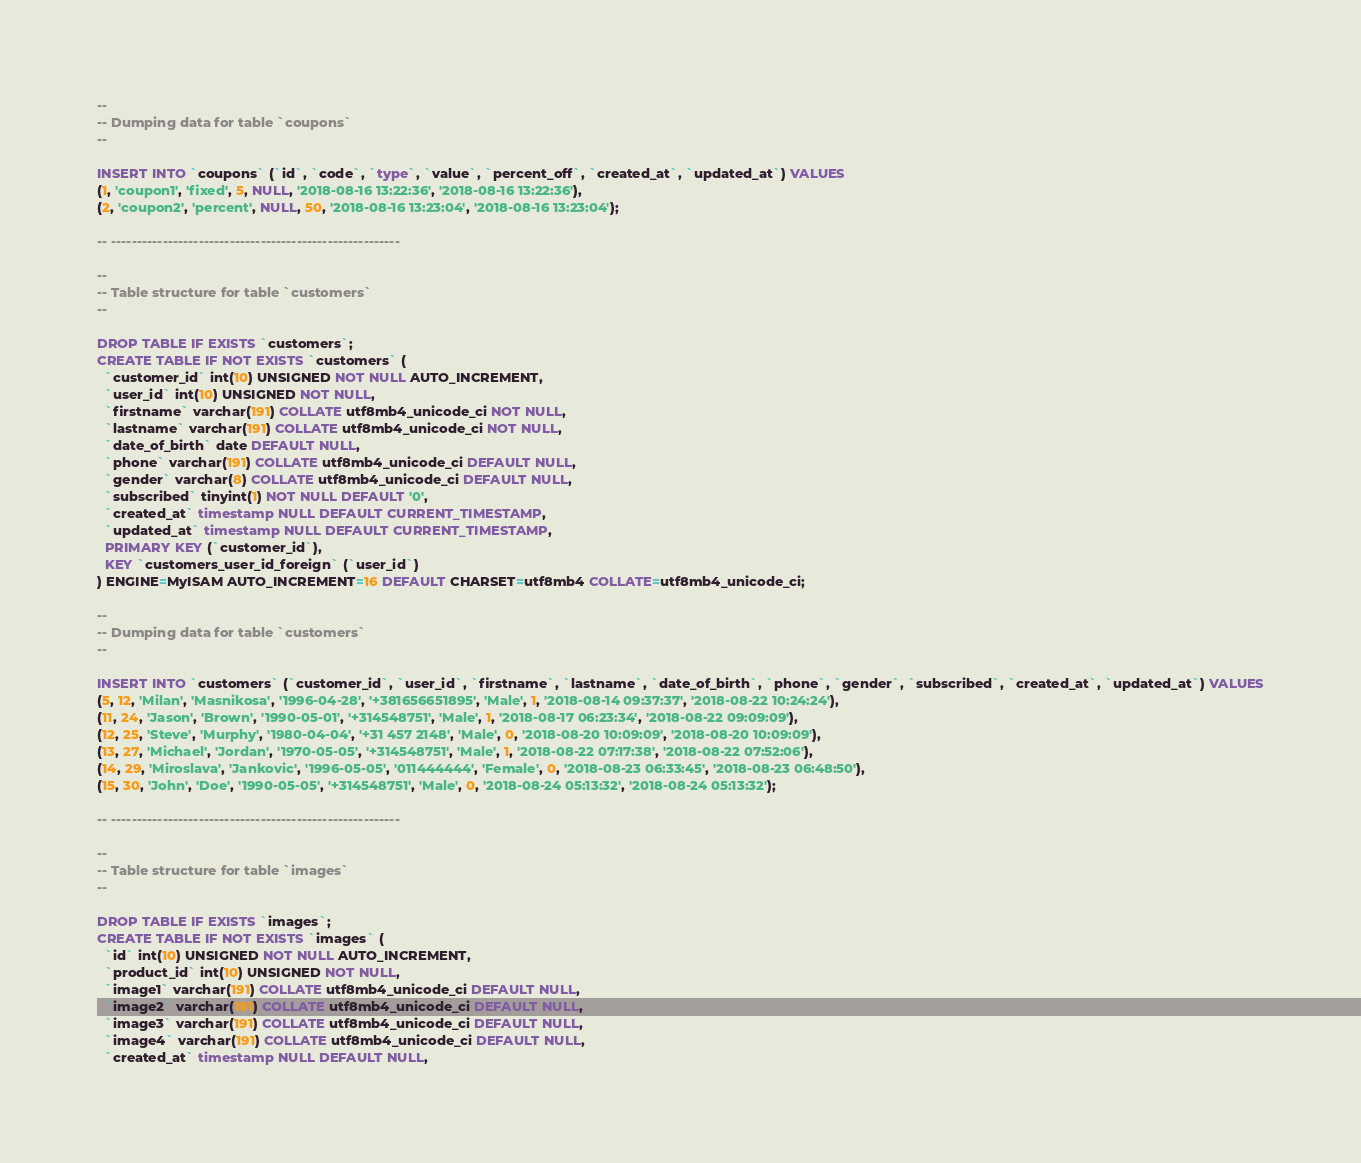Convert code to text. <code><loc_0><loc_0><loc_500><loc_500><_SQL_>--
-- Dumping data for table `coupons`
--

INSERT INTO `coupons` (`id`, `code`, `type`, `value`, `percent_off`, `created_at`, `updated_at`) VALUES
(1, 'coupon1', 'fixed', 5, NULL, '2018-08-16 13:22:36', '2018-08-16 13:22:36'),
(2, 'coupon2', 'percent', NULL, 50, '2018-08-16 13:23:04', '2018-08-16 13:23:04');

-- --------------------------------------------------------

--
-- Table structure for table `customers`
--

DROP TABLE IF EXISTS `customers`;
CREATE TABLE IF NOT EXISTS `customers` (
  `customer_id` int(10) UNSIGNED NOT NULL AUTO_INCREMENT,
  `user_id` int(10) UNSIGNED NOT NULL,
  `firstname` varchar(191) COLLATE utf8mb4_unicode_ci NOT NULL,
  `lastname` varchar(191) COLLATE utf8mb4_unicode_ci NOT NULL,
  `date_of_birth` date DEFAULT NULL,
  `phone` varchar(191) COLLATE utf8mb4_unicode_ci DEFAULT NULL,
  `gender` varchar(8) COLLATE utf8mb4_unicode_ci DEFAULT NULL,
  `subscribed` tinyint(1) NOT NULL DEFAULT '0',
  `created_at` timestamp NULL DEFAULT CURRENT_TIMESTAMP,
  `updated_at` timestamp NULL DEFAULT CURRENT_TIMESTAMP,
  PRIMARY KEY (`customer_id`),
  KEY `customers_user_id_foreign` (`user_id`)
) ENGINE=MyISAM AUTO_INCREMENT=16 DEFAULT CHARSET=utf8mb4 COLLATE=utf8mb4_unicode_ci;

--
-- Dumping data for table `customers`
--

INSERT INTO `customers` (`customer_id`, `user_id`, `firstname`, `lastname`, `date_of_birth`, `phone`, `gender`, `subscribed`, `created_at`, `updated_at`) VALUES
(5, 12, 'Milan', 'Masnikosa', '1996-04-28', '+381656651895', 'Male', 1, '2018-08-14 09:37:37', '2018-08-22 10:24:24'),
(11, 24, 'Jason', 'Brown', '1990-05-01', '+314548751', 'Male', 1, '2018-08-17 06:23:34', '2018-08-22 09:09:09'),
(12, 25, 'Steve', 'Murphy', '1980-04-04', '+31 457 2148', 'Male', 0, '2018-08-20 10:09:09', '2018-08-20 10:09:09'),
(13, 27, 'Michael', 'Jordan', '1970-05-05', '+314548751', 'Male', 1, '2018-08-22 07:17:38', '2018-08-22 07:52:06'),
(14, 29, 'Miroslava', 'Jankovic', '1996-05-05', '011444444', 'Female', 0, '2018-08-23 06:33:45', '2018-08-23 06:48:50'),
(15, 30, 'John', 'Doe', '1990-05-05', '+314548751', 'Male', 0, '2018-08-24 05:13:32', '2018-08-24 05:13:32');

-- --------------------------------------------------------

--
-- Table structure for table `images`
--

DROP TABLE IF EXISTS `images`;
CREATE TABLE IF NOT EXISTS `images` (
  `id` int(10) UNSIGNED NOT NULL AUTO_INCREMENT,
  `product_id` int(10) UNSIGNED NOT NULL,
  `image1` varchar(191) COLLATE utf8mb4_unicode_ci DEFAULT NULL,
  `image2` varchar(191) COLLATE utf8mb4_unicode_ci DEFAULT NULL,
  `image3` varchar(191) COLLATE utf8mb4_unicode_ci DEFAULT NULL,
  `image4` varchar(191) COLLATE utf8mb4_unicode_ci DEFAULT NULL,
  `created_at` timestamp NULL DEFAULT NULL,</code> 